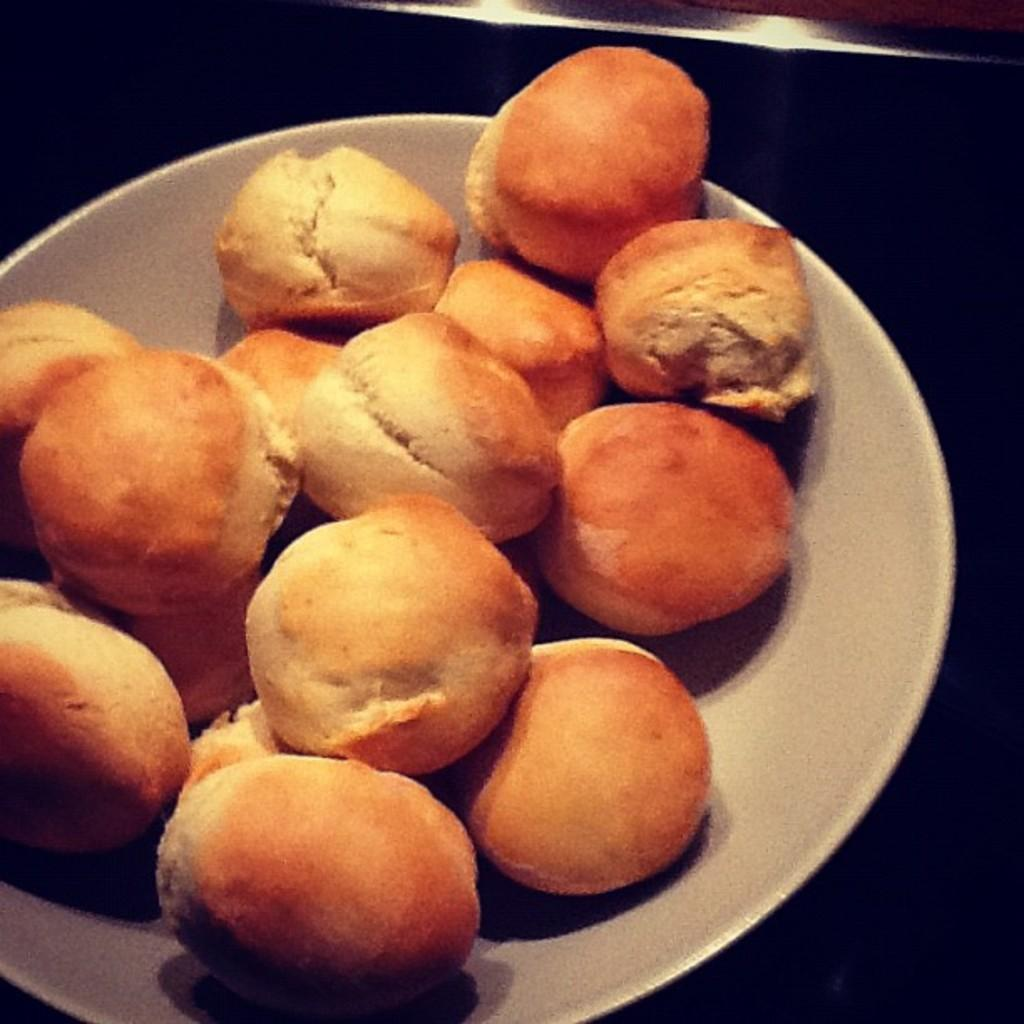What object is visible in the image that is typically used for serving food? There is a plate in the image. What can be found on the plate in the image? There is food present in the image. Can you describe the background of the image? The background of the image is dark. What type of pain can be seen on the person's face in the image? There is no person present in the image, so it is not possible to determine if they are experiencing any pain. 